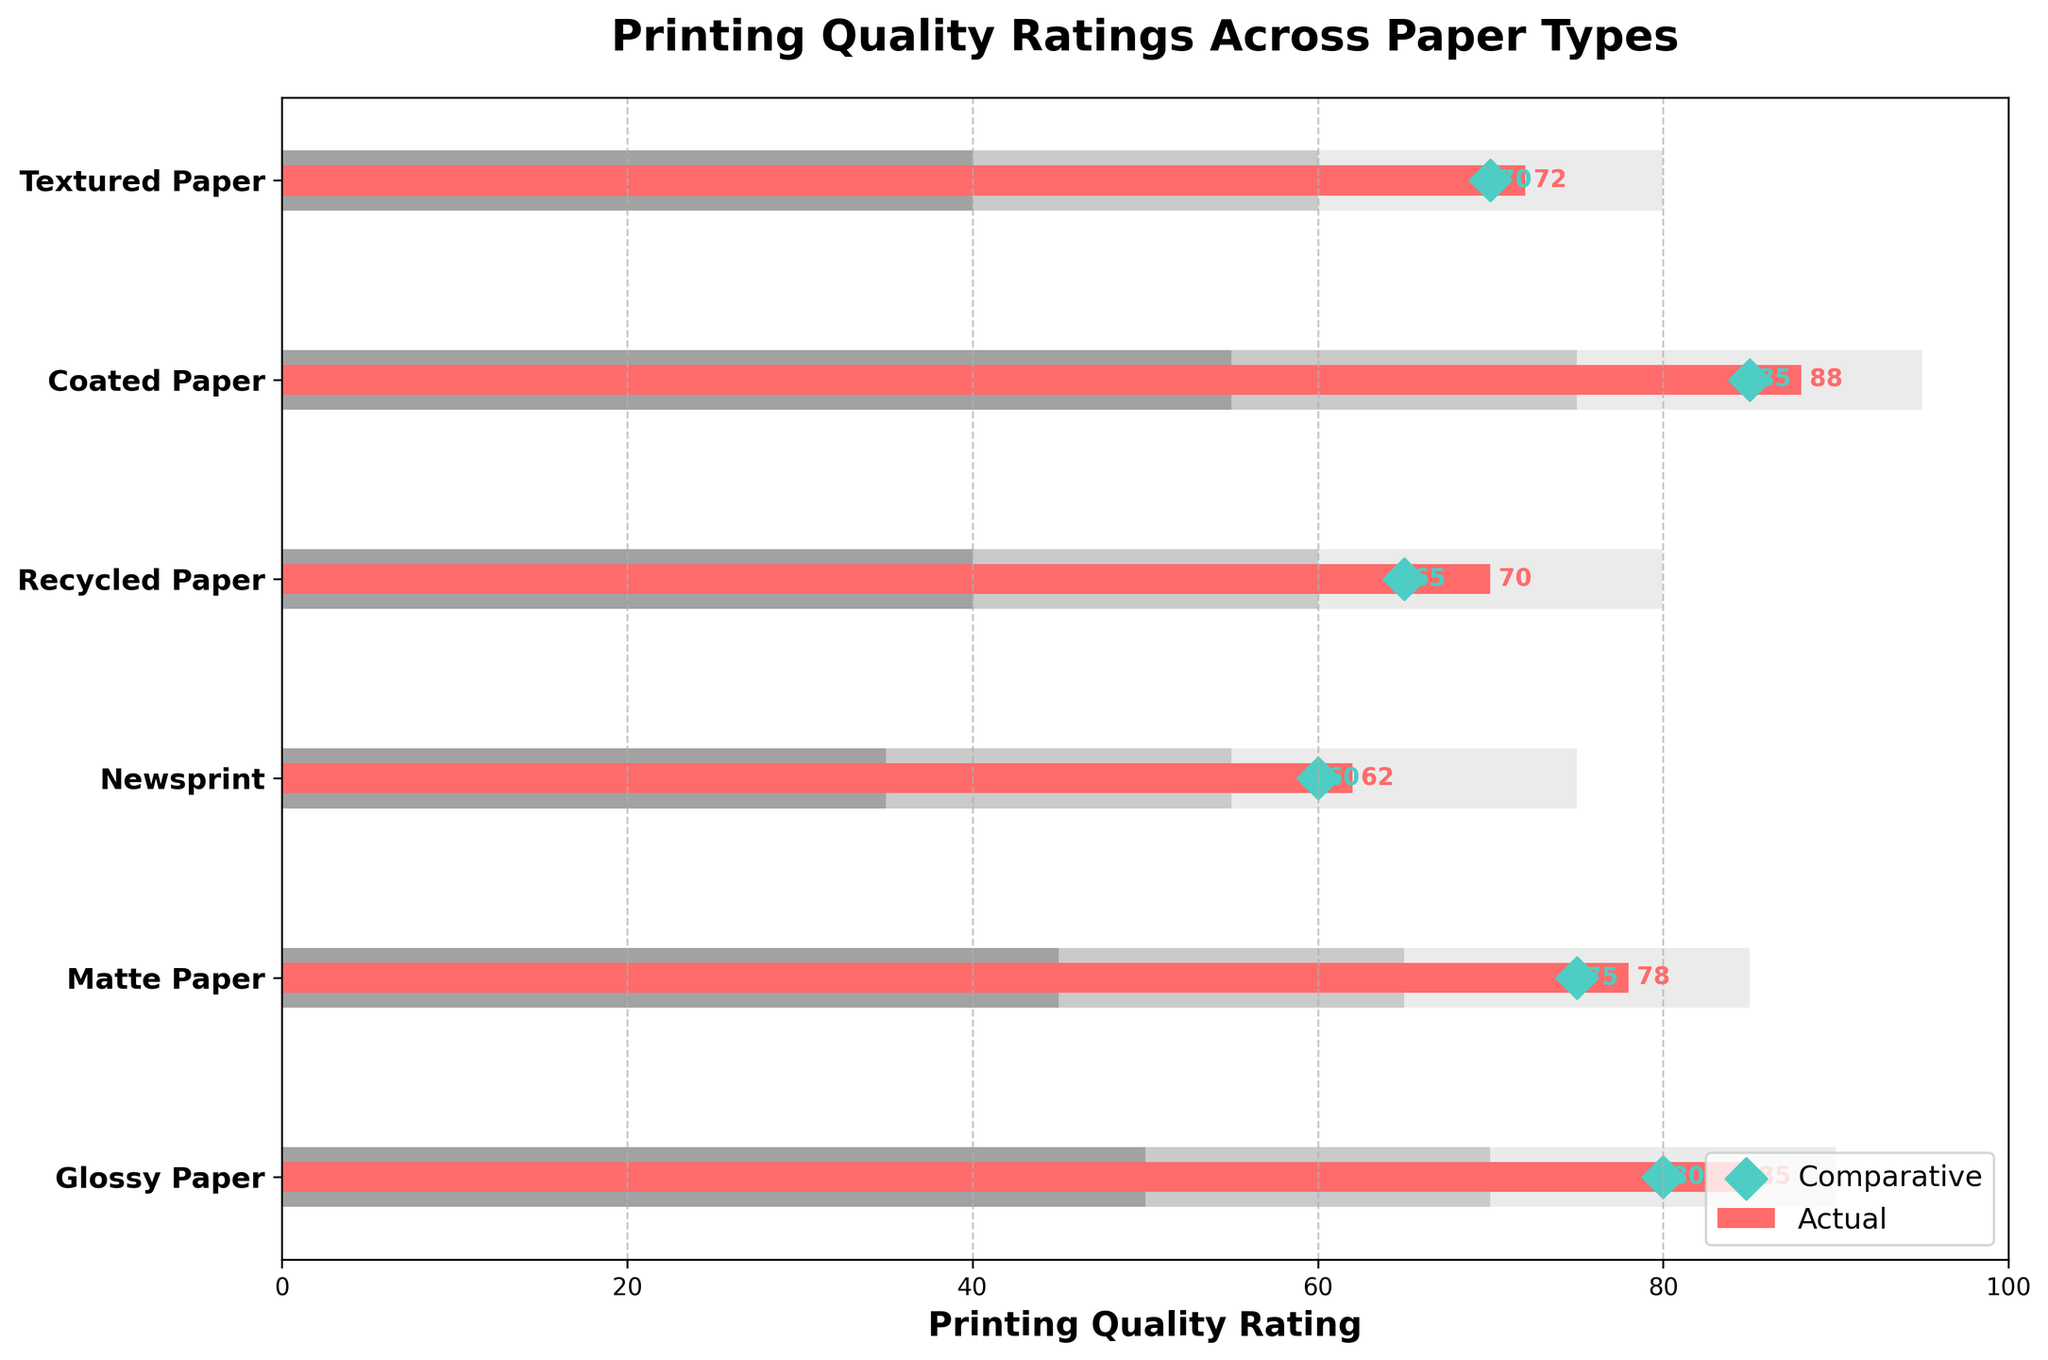What is the title of the plot? The title is located at the top of the figure and gives an overview of the content. It is 'Printing Quality Ratings Across Paper Types'.
Answer: Printing Quality Ratings Across Paper Types How many different paper types are shown in the figure? Count the number of unique labels on the y-axis, which are 'Glossy Paper', 'Matte Paper', 'Newsprint', 'Recycled Paper', 'Coated Paper', and 'Textured Paper'. There are 6 types.
Answer: 6 Which paper type has the highest actual printing quality rating? Look for the longest red bar in the plot, which represents the actual printing quality rating. 'Coated Paper' has the longest red bar with a rating of 88.
Answer: Coated Paper What is the comparative rating for Recycled Paper? Identify the green diamond marker aligned with 'Recycled Paper' on the y-axis. The value next to the marker is 65.
Answer: 65 For Matte Paper, how much higher is the actual rating compared to the comparative rating? Subtract the comparative rating of Matte Paper (75) from the actual rating (78). The difference is 3.
Answer: 3 Which paper type shows the largest discrepancy between actual and comparative ratings? Calculate the absolute difference between the actual and comparative ratings for each paper type. Coated Paper shows the largest discrepancy of 3 (88 - 85).
Answer: Coated Paper Between Glossy Paper and Newsprint, which one has a better actual quality rating? Compare the length of the red bars for 'Glossy Paper' (85) and 'Newsprint' (62). Glossy Paper has a higher actual rating.
Answer: Glossy Paper What is the range of the mid-quality bracket for Coated Paper? Refer to the middle portion of the stacked bar for 'Coated Paper', which is from 75 to 95. The mid-quality bracket is 75 to 95.
Answer: 75 to 95 Which paper type has its actual rating closest to its high-quality range limit? Identify the paper type whose red bar end is closest to the highest limit of its lightest grey section. 'Coated Paper' with an actual rating of 88, compared to its highest limit of 95, is the closest.
Answer: Coated Paper Between Textured Paper and Recycled Paper, which one has a better comparative rating? Compare the values next to the green diamond markers for 'Textured Paper' (70) and 'Recycled Paper' (65). Textured Paper has a higher comparative rating.
Answer: Textured Paper 